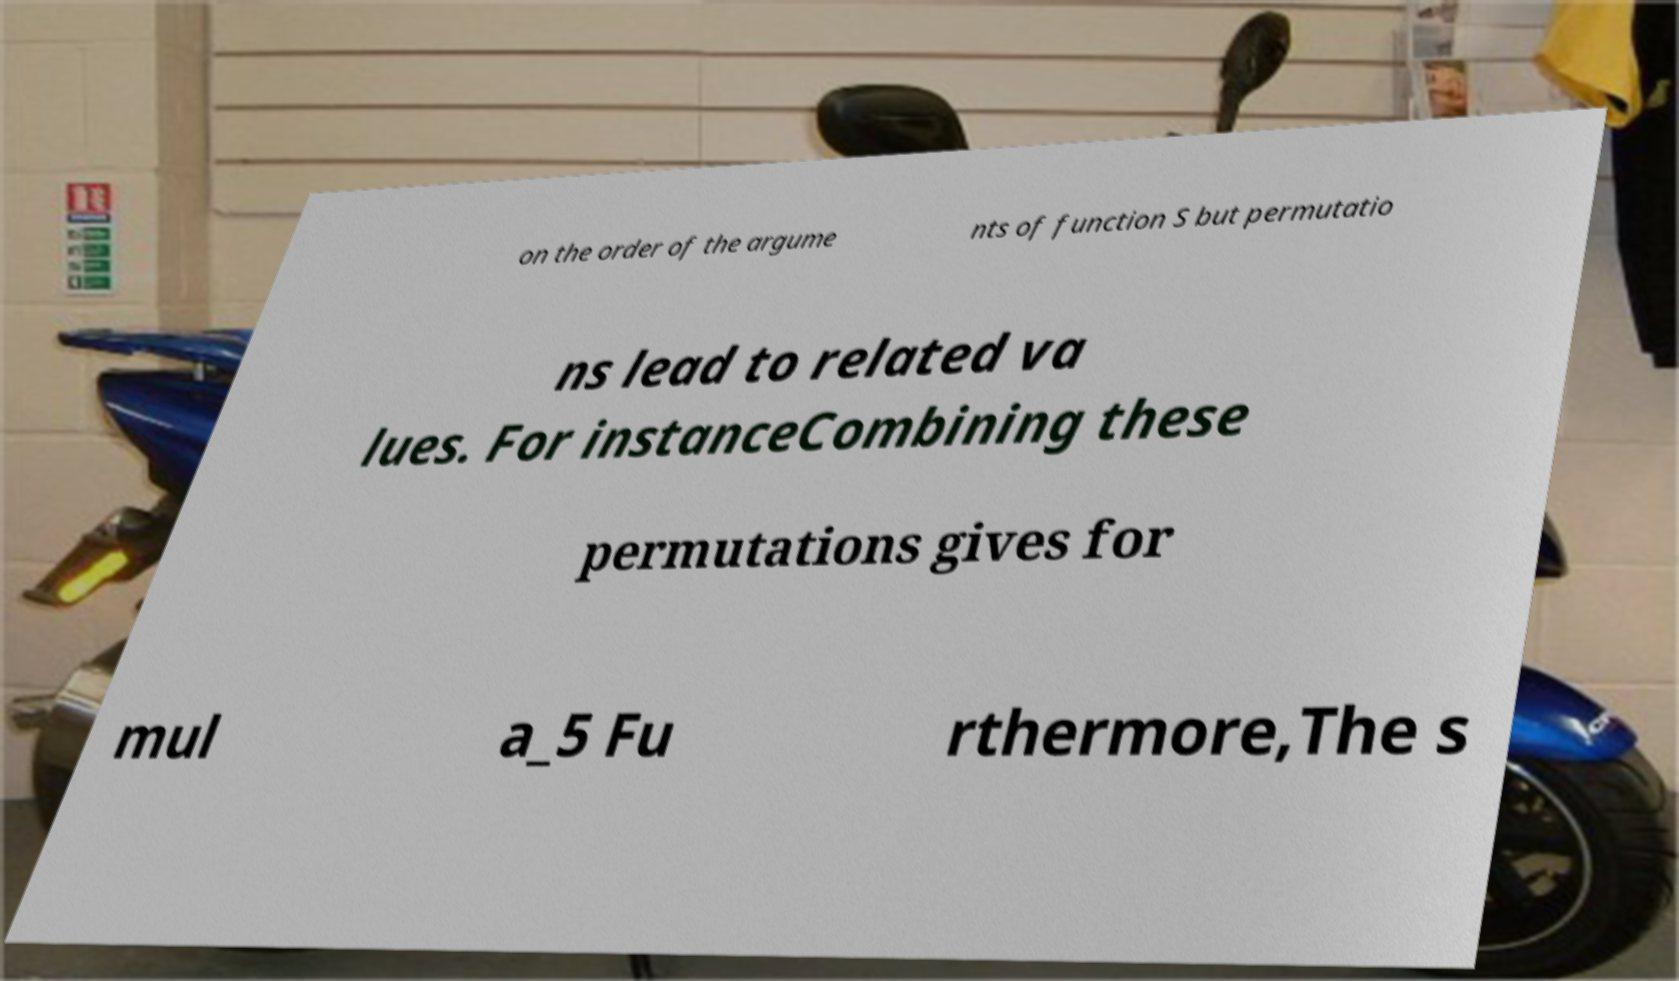What messages or text are displayed in this image? I need them in a readable, typed format. on the order of the argume nts of function S but permutatio ns lead to related va lues. For instanceCombining these permutations gives for mul a_5 Fu rthermore,The s 